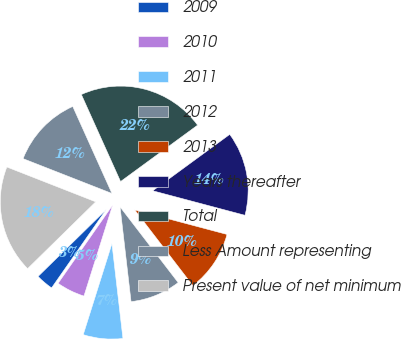Convert chart. <chart><loc_0><loc_0><loc_500><loc_500><pie_chart><fcel>2009<fcel>2010<fcel>2011<fcel>2012<fcel>2013<fcel>Years thereafter<fcel>Total<fcel>Less Amount representing<fcel>Present value of net minimum<nl><fcel>2.96%<fcel>4.83%<fcel>6.7%<fcel>8.58%<fcel>10.45%<fcel>14.19%<fcel>21.68%<fcel>12.32%<fcel>18.29%<nl></chart> 